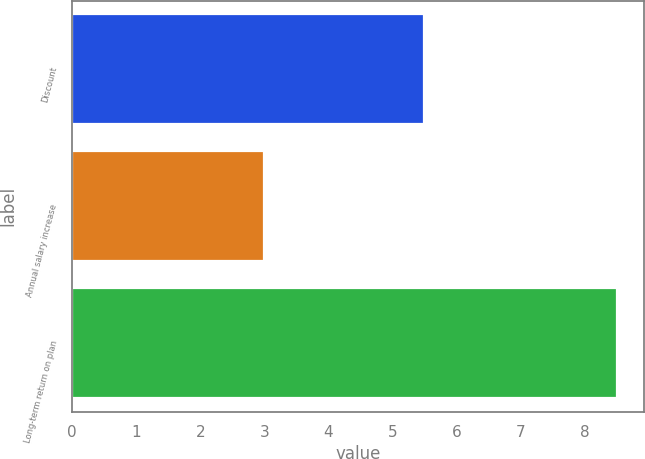Convert chart. <chart><loc_0><loc_0><loc_500><loc_500><bar_chart><fcel>Discount<fcel>Annual salary increase<fcel>Long-term return on plan<nl><fcel>5.5<fcel>3<fcel>8.5<nl></chart> 